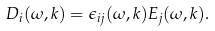<formula> <loc_0><loc_0><loc_500><loc_500>D _ { i } ( \omega , { k } ) = \epsilon _ { i j } ( \omega , { k } ) E _ { j } ( \omega , { k } ) .</formula> 